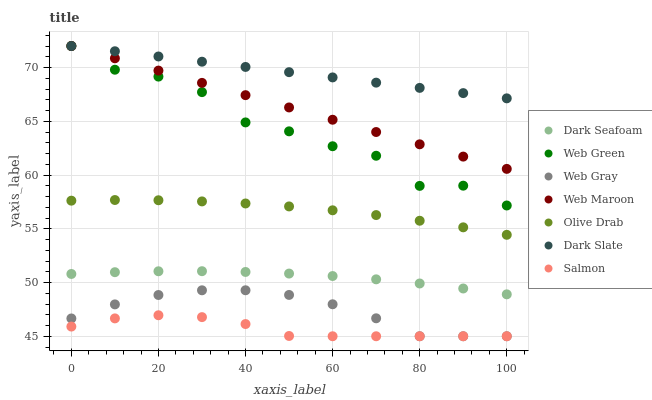Does Salmon have the minimum area under the curve?
Answer yes or no. Yes. Does Dark Slate have the maximum area under the curve?
Answer yes or no. Yes. Does Web Maroon have the minimum area under the curve?
Answer yes or no. No. Does Web Maroon have the maximum area under the curve?
Answer yes or no. No. Is Dark Slate the smoothest?
Answer yes or no. Yes. Is Web Green the roughest?
Answer yes or no. Yes. Is Salmon the smoothest?
Answer yes or no. No. Is Salmon the roughest?
Answer yes or no. No. Does Web Gray have the lowest value?
Answer yes or no. Yes. Does Web Maroon have the lowest value?
Answer yes or no. No. Does Dark Slate have the highest value?
Answer yes or no. Yes. Does Salmon have the highest value?
Answer yes or no. No. Is Olive Drab less than Dark Slate?
Answer yes or no. Yes. Is Dark Slate greater than Olive Drab?
Answer yes or no. Yes. Does Dark Slate intersect Web Maroon?
Answer yes or no. Yes. Is Dark Slate less than Web Maroon?
Answer yes or no. No. Is Dark Slate greater than Web Maroon?
Answer yes or no. No. Does Olive Drab intersect Dark Slate?
Answer yes or no. No. 